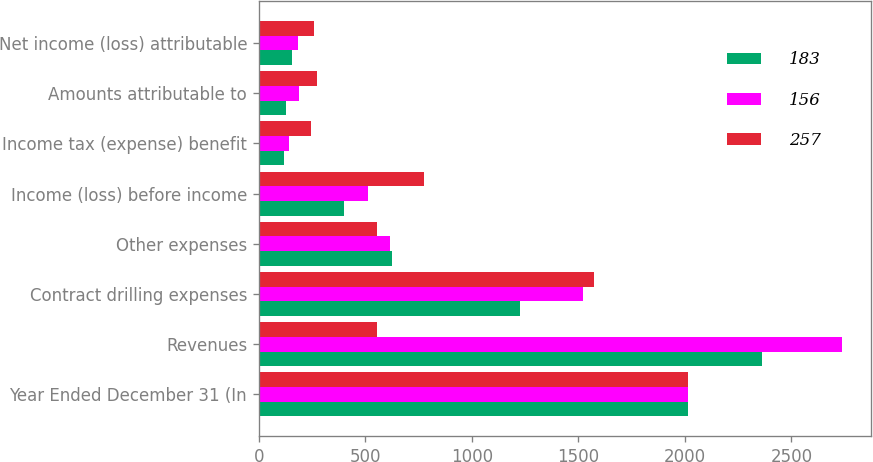Convert chart to OTSL. <chart><loc_0><loc_0><loc_500><loc_500><stacked_bar_chart><ecel><fcel>Year Ended December 31 (In<fcel>Revenues<fcel>Contract drilling expenses<fcel>Other expenses<fcel>Income (loss) before income<fcel>Income tax (expense) benefit<fcel>Amounts attributable to<fcel>Net income (loss) attributable<nl><fcel>183<fcel>2015<fcel>2360<fcel>1228<fcel>627<fcel>402<fcel>117<fcel>129<fcel>156<nl><fcel>156<fcel>2014<fcel>2737<fcel>1524<fcel>616<fcel>514<fcel>142<fcel>189<fcel>183<nl><fcel>257<fcel>2013<fcel>554<fcel>1573<fcel>554<fcel>774<fcel>245<fcel>272<fcel>257<nl></chart> 